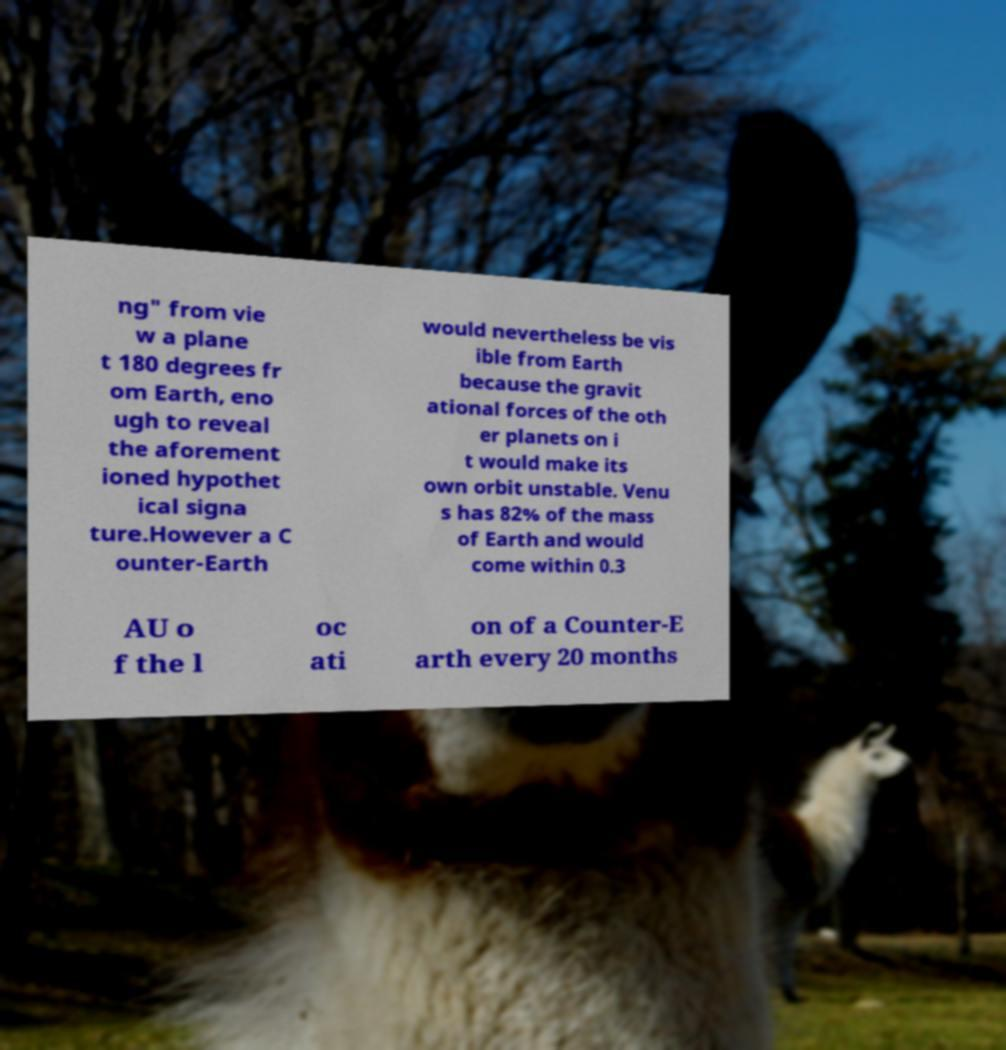Can you accurately transcribe the text from the provided image for me? ng" from vie w a plane t 180 degrees fr om Earth, eno ugh to reveal the aforement ioned hypothet ical signa ture.However a C ounter-Earth would nevertheless be vis ible from Earth because the gravit ational forces of the oth er planets on i t would make its own orbit unstable. Venu s has 82% of the mass of Earth and would come within 0.3 AU o f the l oc ati on of a Counter-E arth every 20 months 